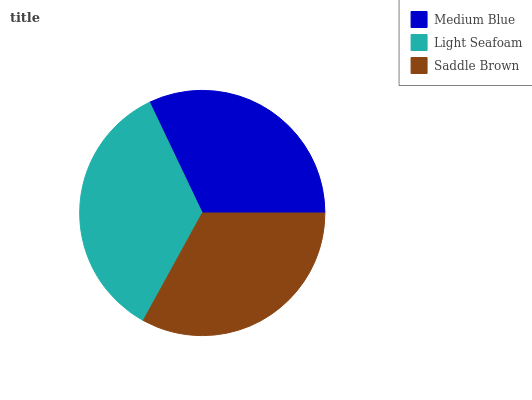Is Medium Blue the minimum?
Answer yes or no. Yes. Is Light Seafoam the maximum?
Answer yes or no. Yes. Is Saddle Brown the minimum?
Answer yes or no. No. Is Saddle Brown the maximum?
Answer yes or no. No. Is Light Seafoam greater than Saddle Brown?
Answer yes or no. Yes. Is Saddle Brown less than Light Seafoam?
Answer yes or no. Yes. Is Saddle Brown greater than Light Seafoam?
Answer yes or no. No. Is Light Seafoam less than Saddle Brown?
Answer yes or no. No. Is Saddle Brown the high median?
Answer yes or no. Yes. Is Saddle Brown the low median?
Answer yes or no. Yes. Is Medium Blue the high median?
Answer yes or no. No. Is Medium Blue the low median?
Answer yes or no. No. 